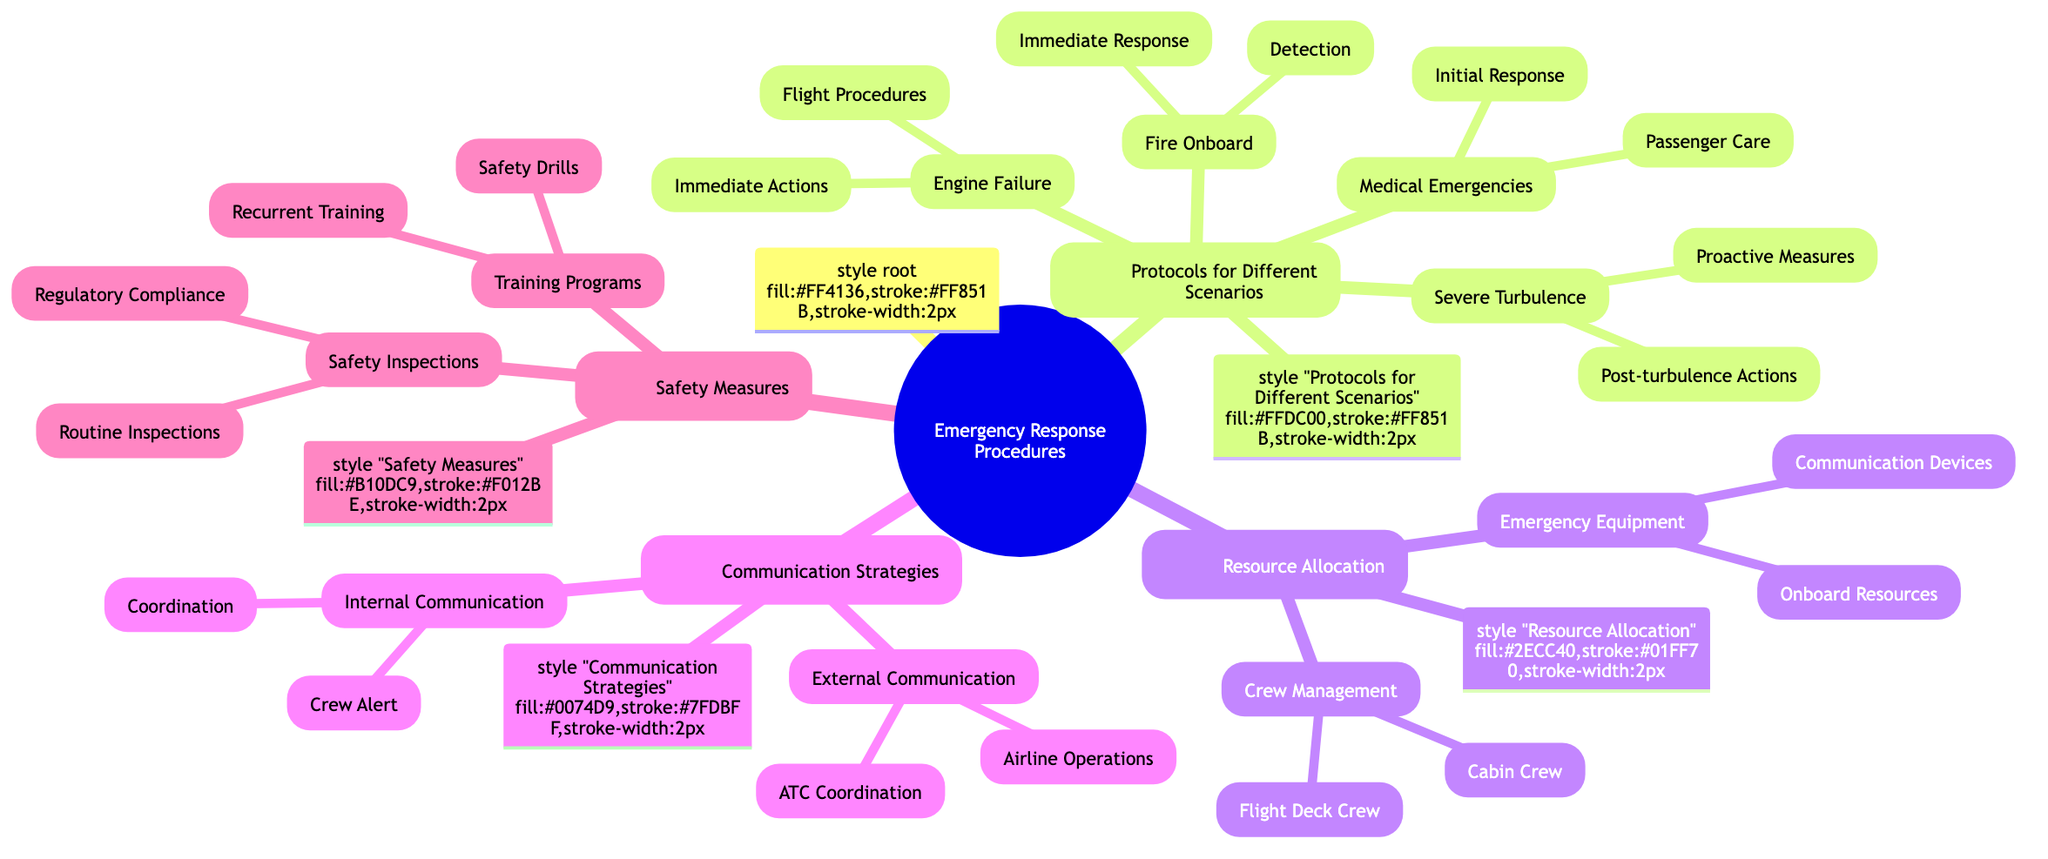What is the main topic of the Mind Map? The main topic is labeled as "Emergency Response Procedures" at the root of the diagram.
Answer: Emergency Response Procedures How many scenarios are listed under "Protocols for Different Scenarios"? There are four scenarios mentioned: Engine Failure, Medical Emergencies, Fire Onboard, and Severe Turbulence, which can be counted directly from the nodes.
Answer: 4 What are the immediate actions listed for engine failure? Under the "Engine Failure" node, the immediate actions are specifically enumerated: Throttle IDLE, Fuel Cutoff, Ignition OFF, and ATC Notification.
Answer: Throttle IDLE, Fuel Cutoff, Ignition OFF, ATC Notification What resources are included under "Emergency Equipment"? The "Emergency Equipment" node includes both "Onboard Resources" and "Communication Devices" as sub-nodes, indicating two categories of resources.
Answer: Onboard Resources, Communication Devices Which communication method is categorized under "Internal Communication"? The "Internal Communication" node enumerates "Crew Alert" as a method, which specifically lists the intercom system and cabin announcements.
Answer: Crew Alert What is included in "Safety Measures"? "Safety Measures" consists of two sub-categories: "Training Programs" and "Safety Inspections," which can be directly identified from the diagram.
Answer: Training Programs, Safety Inspections How many immediate responses are listed under "Fire Onboard"? The "Fire Onboard" node has three immediate responses: Notify ATC, Activate Fire Extinguishers, Turn Off Non-essential Electrical Systems, which can be counted from the sub-node.
Answer: 3 What is the purpose of "Emergency Squawk 7700"? "Emergency Squawk 7700" is listed under "ATC Coordination" in "External Communication," indicating its purpose is to signal an emergency to air traffic control.
Answer: Signal an emergency What type of training programs are mentioned in "Training Programs"? The "Training Programs" node highlights two types: "Recurrent Training" and "Safety Drills," which can be identified from the respective sub-nodes.
Answer: Recurrent Training, Safety Drills 